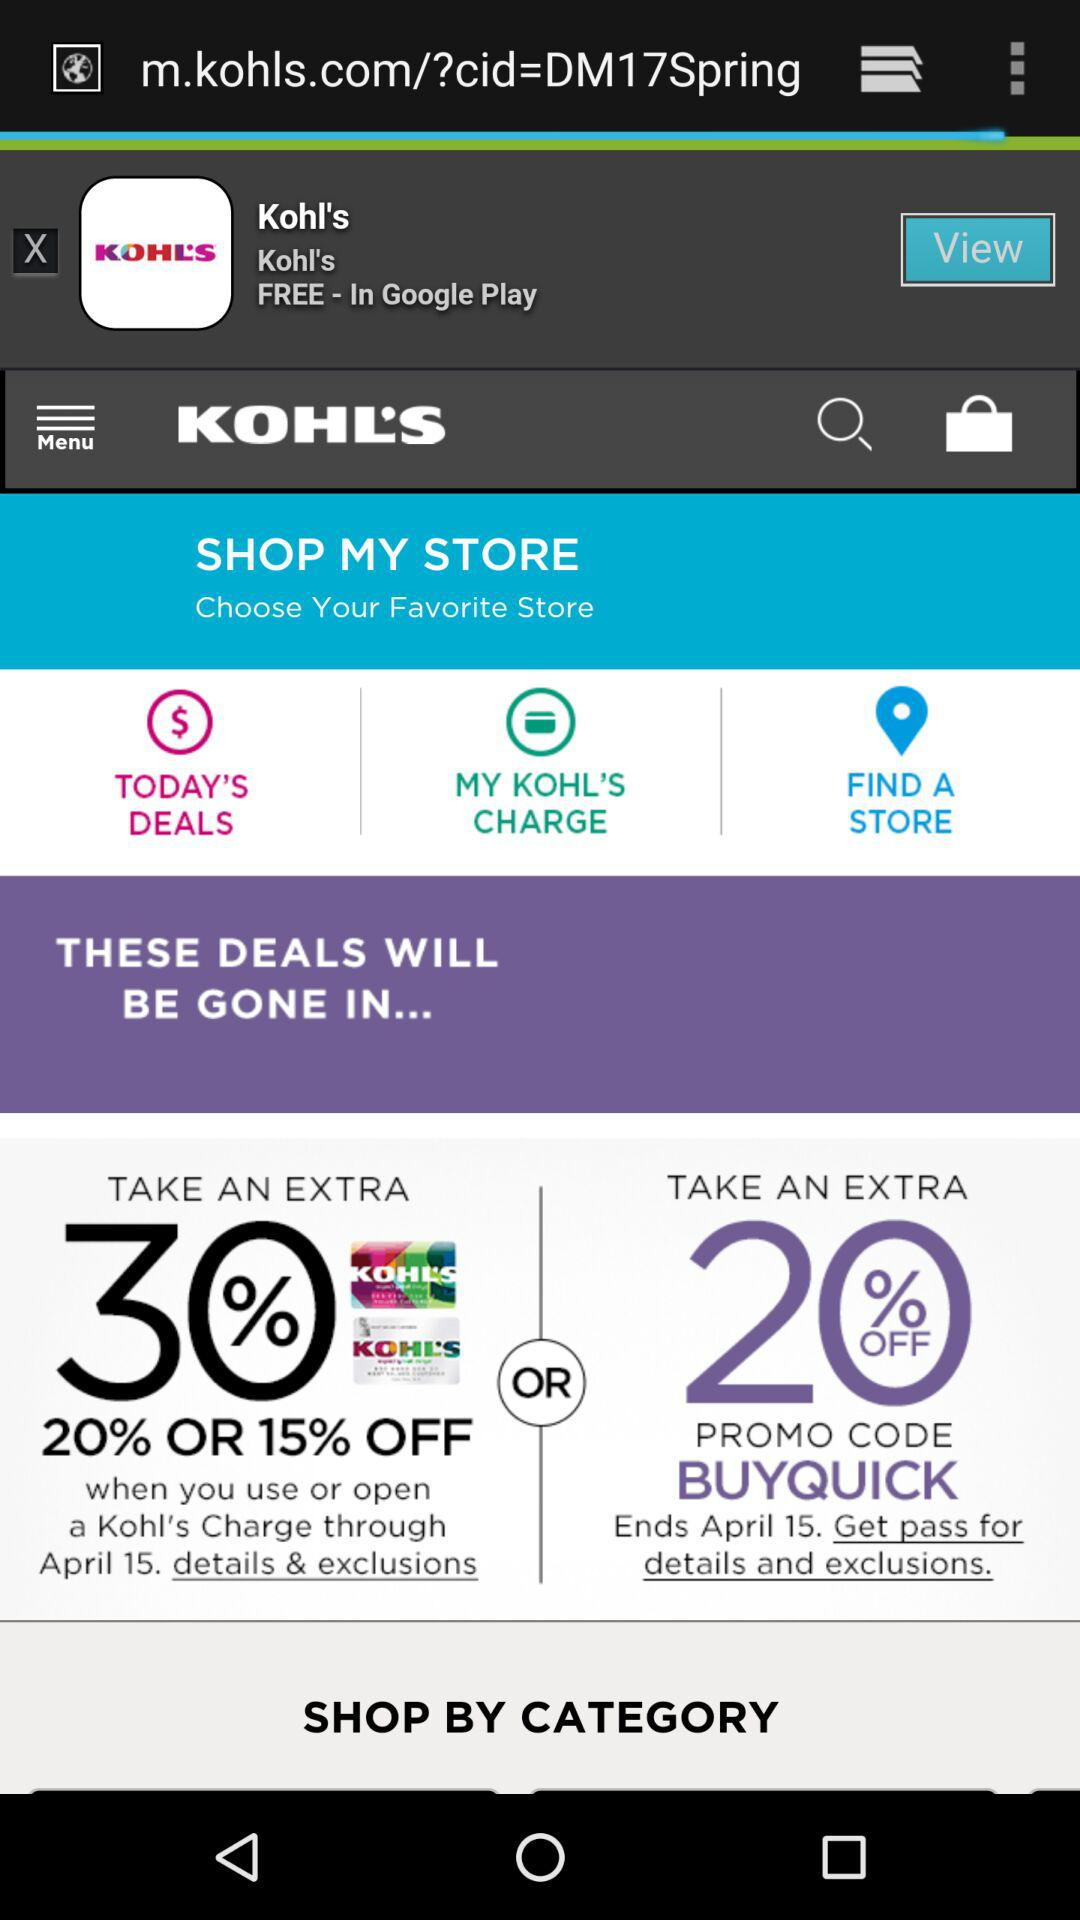How many deals are there?
Answer the question using a single word or phrase. 2 